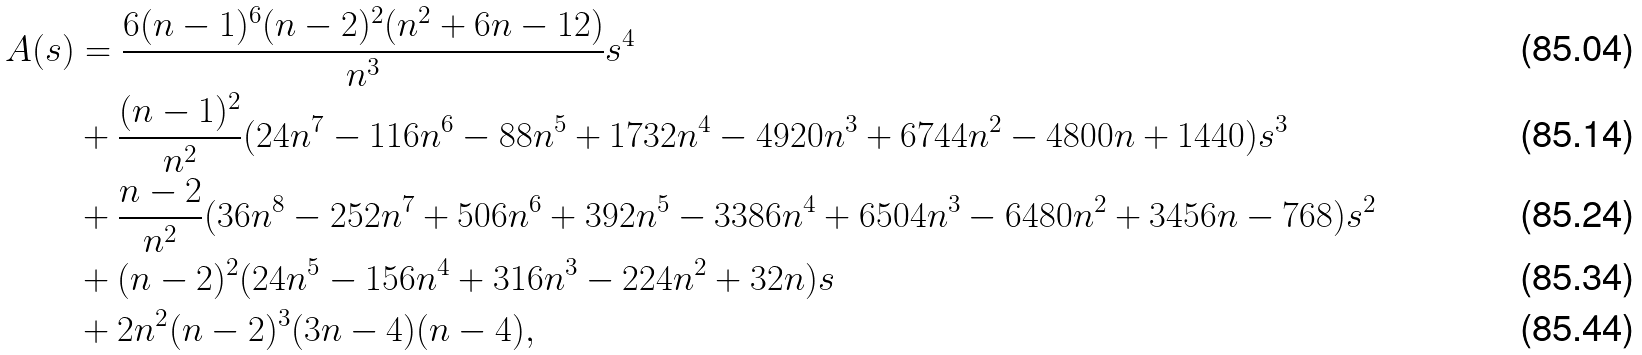<formula> <loc_0><loc_0><loc_500><loc_500>A ( s ) & = \frac { 6 ( n - 1 ) ^ { 6 } ( n - 2 ) ^ { 2 } ( n ^ { 2 } + 6 n - 1 2 ) } { n ^ { 3 } } s ^ { 4 } \\ & + \frac { ( n - 1 ) ^ { 2 } } { n ^ { 2 } } ( 2 4 n ^ { 7 } - 1 1 6 n ^ { 6 } - 8 8 n ^ { 5 } + 1 7 3 2 n ^ { 4 } - 4 9 2 0 n ^ { 3 } + 6 7 4 4 n ^ { 2 } - 4 8 0 0 n + 1 4 4 0 ) s ^ { 3 } \\ & + \frac { n - 2 } { n ^ { 2 } } ( 3 6 n ^ { 8 } - 2 5 2 n ^ { 7 } + 5 0 6 n ^ { 6 } + 3 9 2 n ^ { 5 } - 3 3 8 6 n ^ { 4 } + 6 5 0 4 n ^ { 3 } - 6 4 8 0 n ^ { 2 } + 3 4 5 6 n - 7 6 8 ) s ^ { 2 } \\ & + ( n - 2 ) ^ { 2 } ( 2 4 n ^ { 5 } - 1 5 6 n ^ { 4 } + 3 1 6 n ^ { 3 } - 2 2 4 n ^ { 2 } + 3 2 n ) s \\ & + 2 n ^ { 2 } ( n - 2 ) ^ { 3 } ( 3 n - 4 ) ( n - 4 ) ,</formula> 